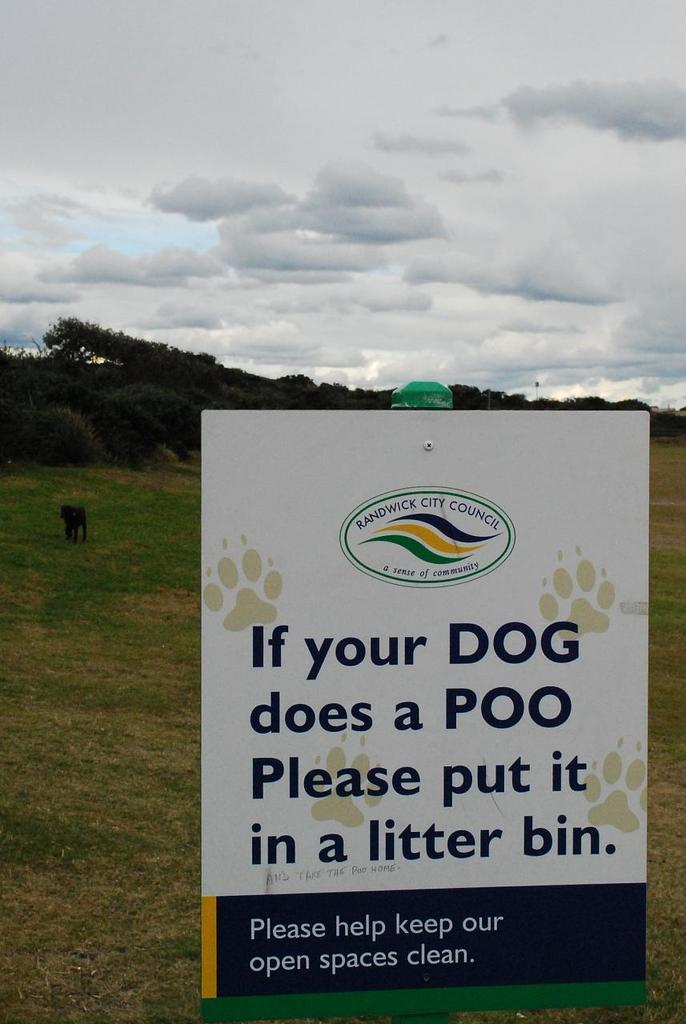What is the main object in the image? There is a board in the image. What type of living creature can be seen in the image? There is an animal in the image. What is the natural environment depicted in the image? There is grass and trees in the image. What can be seen in the background of the image? The sky is visible in the background of the image, and clouds are present in the sky. What advertisement is displayed on the board in the image? There is no advertisement present on the board in the image. What type of plough is being used by the animal in the image? There is no plough present in the image; the animal is not performing any agricultural activity. 